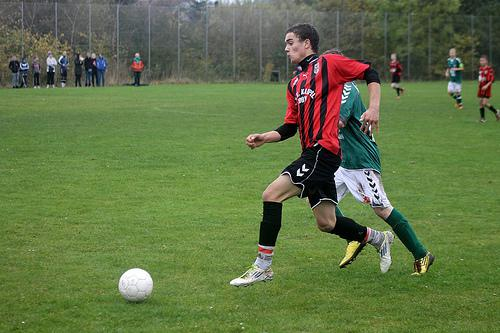Question: what game is being played?
Choices:
A. Soccer.
B. Football.
C. Baseball.
D. Rugby.
Answer with the letter. Answer: A Question: how many players on the green team are shown?
Choices:
A. Three.
B. Four.
C. Two.
D. Five.
Answer with the letter. Answer: C Question: where is this game played?
Choices:
A. Tennis court.
B. Soccer field.
C. Football field.
D. Basketball court.
Answer with the letter. Answer: B Question: what are the players running on?
Choices:
A. Dirt.
B. Grass.
C. Concrete.
D. Wood.
Answer with the letter. Answer: B Question: how many players are wearing red?
Choices:
A. Two.
B. Three.
C. Four.
D. Eight.
Answer with the letter. Answer: B Question: what color is the ball?
Choices:
A. Green.
B. Yellow.
C. White.
D. Blue.
Answer with the letter. Answer: C 